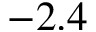Convert formula to latex. <formula><loc_0><loc_0><loc_500><loc_500>- 2 . 4</formula> 